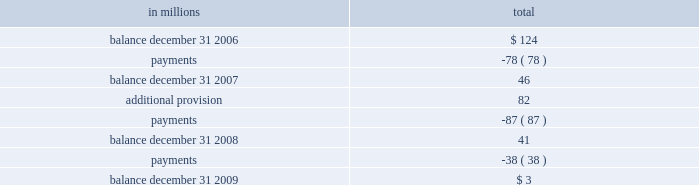Working on the site .
The company resolved five of the eight pending lawsuits arising from this matter and believes that it has adequate insurance to resolve remaining matters .
The company believes that the settlement of these lawsuits will not have a material adverse effect on its consolidated financial statements .
During the 2009 third quarter , in connection with an environmental site remediation action under cer- cla , international paper submitted to the epa a feasibility study for this site .
The epa has indicated that it intends to select a proposed remedial action alternative from those identified in the study and present this proposal for public comment .
Since it is not currently possible to determine the final remedial action that will be required , the company has accrued , as of december 31 , 2009 , an estimate of the minimum costs that could be required for this site .
When the remediation plan is finalized by the epa , it is possible that the remediation costs could be sig- nificantly higher than amounts currently recorded .
Exterior siding and roofing litigation international paper has established reserves relating to the settlement , during 1998 and 1999 , of three nationwide class action lawsuits against the com- pany and masonite corp. , a former wholly-owned subsidiary of the company .
Those settlements relate to ( 1 ) exterior hardboard siding installed during the 1980 2019s and 1990 2019s ( the hardboard claims ) ; ( 2 ) omniwood siding installed during the 1990 2019s ( the omniwood claims ) ; and ( 3 ) woodruf roofing installed during the 1980 2019s and 1990 2019s ( the woodruf claims ) .
All hardboard claims were required to be made by january 15 , 2008 , while all omniwood and woodruf claims were required to be made by jan- uary 6 , 2009 .
The table presents an analysis of total reserve activity related to the hardboard , omniwood and woodruf settlements for the years ended december 31 , 2009 , 2008 and 2007 : in millions total .
The company believes that the aggregate reserve balance remaining at december 31 , 2009 is adequate to cover the final settlement of remaining claims .
Summary the company is also involved in various other inquiries , administrative proceedings and litigation relating to contracts , sales of property , intellectual property , environmental and safety matters , tax , personal injury , labor and employment and other matters , some of which allege substantial monetary damages .
While any proceeding or litigation has the element of uncertainty , the company believes that the outcome of any of the lawsuits or claims that are pending or threatened , or all of them combined , will not have a material adverse effect on its consolidated financial statements .
Note 12 variable interest entities and preferred securities of subsidiaries variable interest entities in connection with the 2006 sale of approximately 5.6 million acres of forestlands , international paper received installment notes ( the timber notes ) total- ing approximately $ 4.8 billion .
The timber notes , which do not require principal payments prior to their august 2016 maturity , are supported by irrev- ocable letters of credit obtained by the buyers of the forestlands .
During the 2006 fourth quarter , interna- tional paper contributed the timber notes to newly formed entities ( the borrower entities ) in exchange for class a and class b interests in these entities .
Subsequently , international paper contributed its $ 200 million class a interests in the borrower enti- ties , along with approximately $ 400 million of international paper promissory notes , to other newly formed entities ( the investor entities ) in exchange for class a and class b interests in these entities , and simultaneously sold its class a interest in the investor entities to a third party investor .
As a result , at december 31 , 2006 , international paper held class b interests in the borrower entities and class b interests in the investor entities valued at approx- imately $ 5.0 billion .
International paper has no obligation to make any further capital contributions to these entities and did not provide financial or other support during 2009 , 2008 or 2007 that was not previously contractually required .
Based on an analysis of these entities under guidance that considers the potential magnitude of the variability in the structure and which party bears a majority of the gains or losses , international paper determined that it is not the primary beneficiary of these entities .
In 2006 what was the ratio of the class a shares and promissory notes international paper contributed in the acquisition of borrower entities interest? 
Computations: (200 / 400)
Answer: 0.5. 